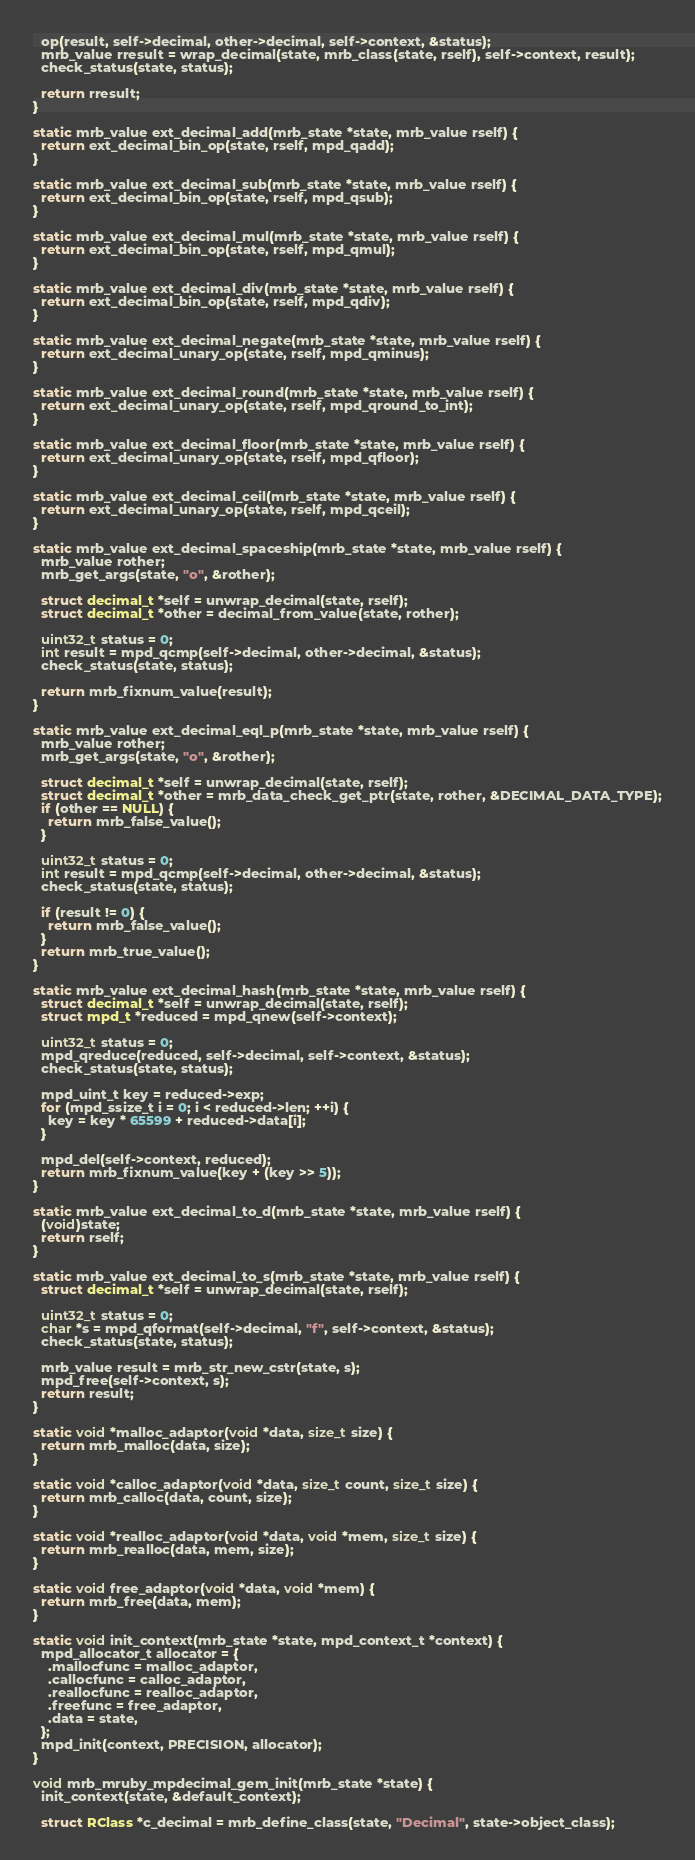<code> <loc_0><loc_0><loc_500><loc_500><_C_>  op(result, self->decimal, other->decimal, self->context, &status);
  mrb_value rresult = wrap_decimal(state, mrb_class(state, rself), self->context, result);
  check_status(state, status);

  return rresult;
}

static mrb_value ext_decimal_add(mrb_state *state, mrb_value rself) {
  return ext_decimal_bin_op(state, rself, mpd_qadd);
}

static mrb_value ext_decimal_sub(mrb_state *state, mrb_value rself) {
  return ext_decimal_bin_op(state, rself, mpd_qsub);
}

static mrb_value ext_decimal_mul(mrb_state *state, mrb_value rself) {
  return ext_decimal_bin_op(state, rself, mpd_qmul);
}

static mrb_value ext_decimal_div(mrb_state *state, mrb_value rself) {
  return ext_decimal_bin_op(state, rself, mpd_qdiv);
}

static mrb_value ext_decimal_negate(mrb_state *state, mrb_value rself) {
  return ext_decimal_unary_op(state, rself, mpd_qminus);
}

static mrb_value ext_decimal_round(mrb_state *state, mrb_value rself) {
  return ext_decimal_unary_op(state, rself, mpd_qround_to_int);
}

static mrb_value ext_decimal_floor(mrb_state *state, mrb_value rself) {
  return ext_decimal_unary_op(state, rself, mpd_qfloor);
}

static mrb_value ext_decimal_ceil(mrb_state *state, mrb_value rself) {
  return ext_decimal_unary_op(state, rself, mpd_qceil);
}

static mrb_value ext_decimal_spaceship(mrb_state *state, mrb_value rself) {
  mrb_value rother;
  mrb_get_args(state, "o", &rother);

  struct decimal_t *self = unwrap_decimal(state, rself);
  struct decimal_t *other = decimal_from_value(state, rother);

  uint32_t status = 0;
  int result = mpd_qcmp(self->decimal, other->decimal, &status);
  check_status(state, status);

  return mrb_fixnum_value(result);
}

static mrb_value ext_decimal_eql_p(mrb_state *state, mrb_value rself) {
  mrb_value rother;
  mrb_get_args(state, "o", &rother);

  struct decimal_t *self = unwrap_decimal(state, rself);
  struct decimal_t *other = mrb_data_check_get_ptr(state, rother, &DECIMAL_DATA_TYPE);
  if (other == NULL) {
    return mrb_false_value();
  }

  uint32_t status = 0;
  int result = mpd_qcmp(self->decimal, other->decimal, &status);
  check_status(state, status);

  if (result != 0) {
    return mrb_false_value();
  }
  return mrb_true_value();
}

static mrb_value ext_decimal_hash(mrb_state *state, mrb_value rself) {
  struct decimal_t *self = unwrap_decimal(state, rself);
  struct mpd_t *reduced = mpd_qnew(self->context);

  uint32_t status = 0;
  mpd_qreduce(reduced, self->decimal, self->context, &status);
  check_status(state, status);

  mpd_uint_t key = reduced->exp;
  for (mpd_ssize_t i = 0; i < reduced->len; ++i) {
    key = key * 65599 + reduced->data[i];
  }

  mpd_del(self->context, reduced);
  return mrb_fixnum_value(key + (key >> 5));
}

static mrb_value ext_decimal_to_d(mrb_state *state, mrb_value rself) {
  (void)state;
  return rself;
}

static mrb_value ext_decimal_to_s(mrb_state *state, mrb_value rself) {
  struct decimal_t *self = unwrap_decimal(state, rself);

  uint32_t status = 0;
  char *s = mpd_qformat(self->decimal, "f", self->context, &status);
  check_status(state, status);

  mrb_value result = mrb_str_new_cstr(state, s);
  mpd_free(self->context, s);
  return result;
}

static void *malloc_adaptor(void *data, size_t size) {
  return mrb_malloc(data, size);
}

static void *calloc_adaptor(void *data, size_t count, size_t size) {
  return mrb_calloc(data, count, size);
}

static void *realloc_adaptor(void *data, void *mem, size_t size) {
  return mrb_realloc(data, mem, size);
}

static void free_adaptor(void *data, void *mem) {
  return mrb_free(data, mem);
}

static void init_context(mrb_state *state, mpd_context_t *context) {
  mpd_allocator_t allocator = {
    .mallocfunc = malloc_adaptor,
    .callocfunc = calloc_adaptor,
    .reallocfunc = realloc_adaptor,
    .freefunc = free_adaptor,
    .data = state,
  };
  mpd_init(context, PRECISION, allocator);
}

void mrb_mruby_mpdecimal_gem_init(mrb_state *state) {
  init_context(state, &default_context);

  struct RClass *c_decimal = mrb_define_class(state, "Decimal", state->object_class);</code> 